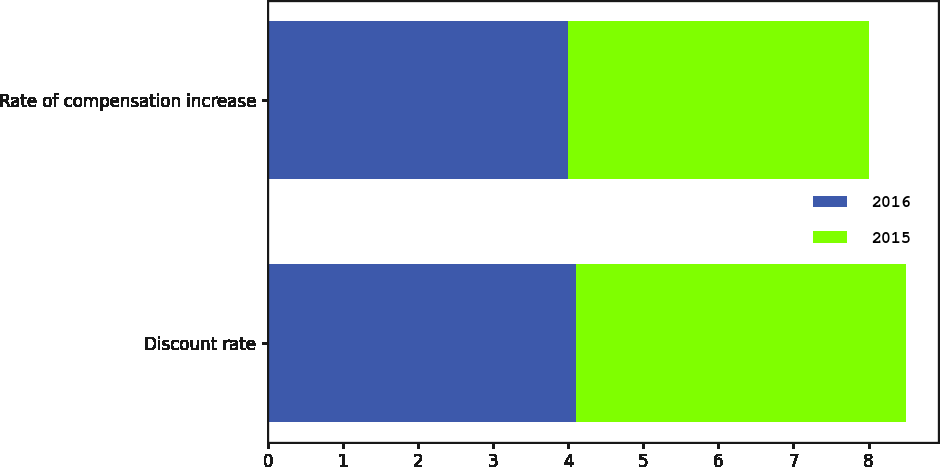<chart> <loc_0><loc_0><loc_500><loc_500><stacked_bar_chart><ecel><fcel>Discount rate<fcel>Rate of compensation increase<nl><fcel>2016<fcel>4.1<fcel>4<nl><fcel>2015<fcel>4.4<fcel>4<nl></chart> 